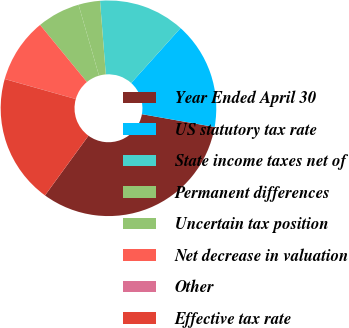<chart> <loc_0><loc_0><loc_500><loc_500><pie_chart><fcel>Year Ended April 30<fcel>US statutory tax rate<fcel>State income taxes net of<fcel>Permanent differences<fcel>Uncertain tax position<fcel>Net decrease in valuation<fcel>Other<fcel>Effective tax rate<nl><fcel>32.24%<fcel>16.13%<fcel>12.9%<fcel>3.23%<fcel>6.46%<fcel>9.68%<fcel>0.01%<fcel>19.35%<nl></chart> 